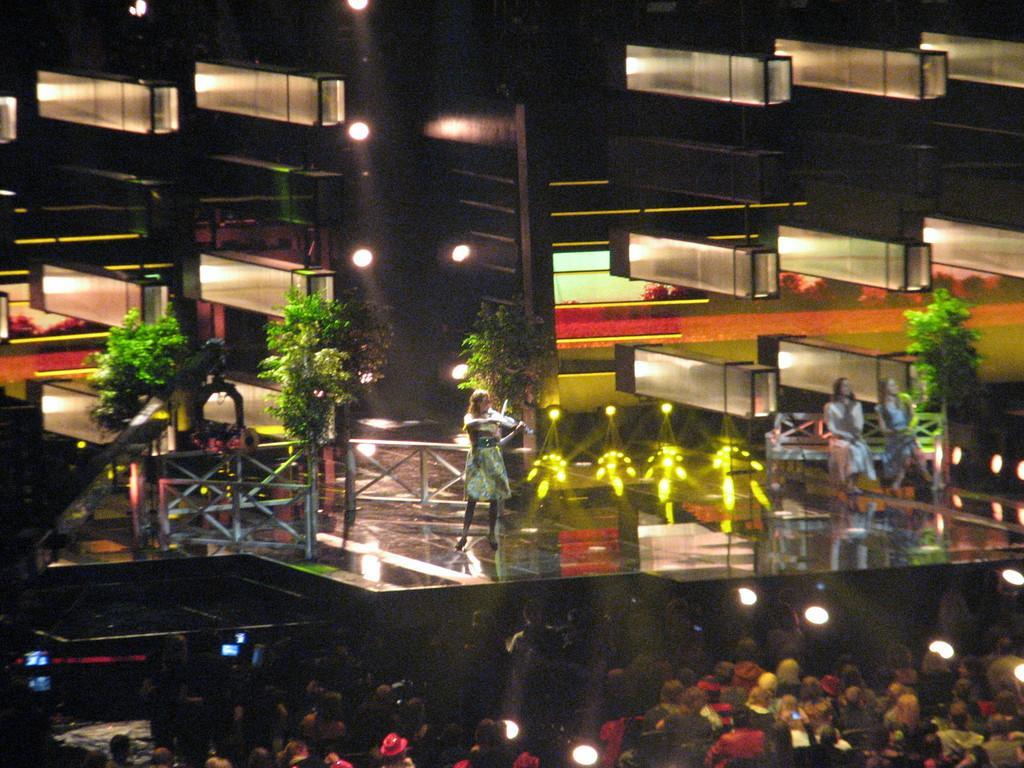Describe this image in one or two sentences. In the foreground of the picture there are audience, lights. In the picture there is a woman standing and playing violin. On the right there are women sitting on bench. In the center of the picture there are trees. At the top there are lights and building. 